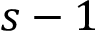Convert formula to latex. <formula><loc_0><loc_0><loc_500><loc_500>s - 1</formula> 